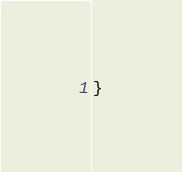<code> <loc_0><loc_0><loc_500><loc_500><_Kotlin_>}
</code> 